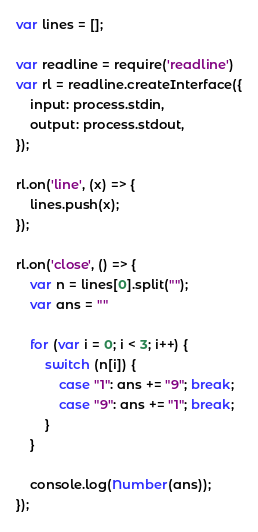Convert code to text. <code><loc_0><loc_0><loc_500><loc_500><_JavaScript_>var lines = [];

var readline = require('readline')
var rl = readline.createInterface({
    input: process.stdin,
    output: process.stdout,
});

rl.on('line', (x) => {
    lines.push(x);
});

rl.on('close', () => {
    var n = lines[0].split("");
    var ans = ""

    for (var i = 0; i < 3; i++) {
        switch (n[i]) {
            case "1": ans += "9"; break;
            case "9": ans += "1"; break;
        }
    }

    console.log(Number(ans));
});</code> 